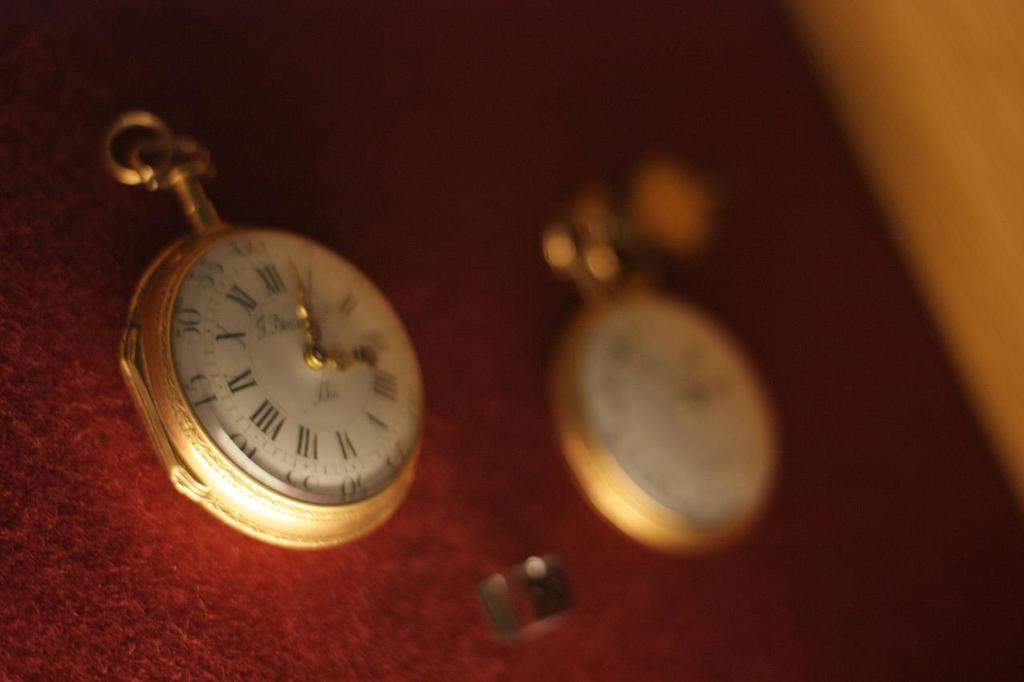What times does the first watch read?
Provide a succinct answer. 3:03. 